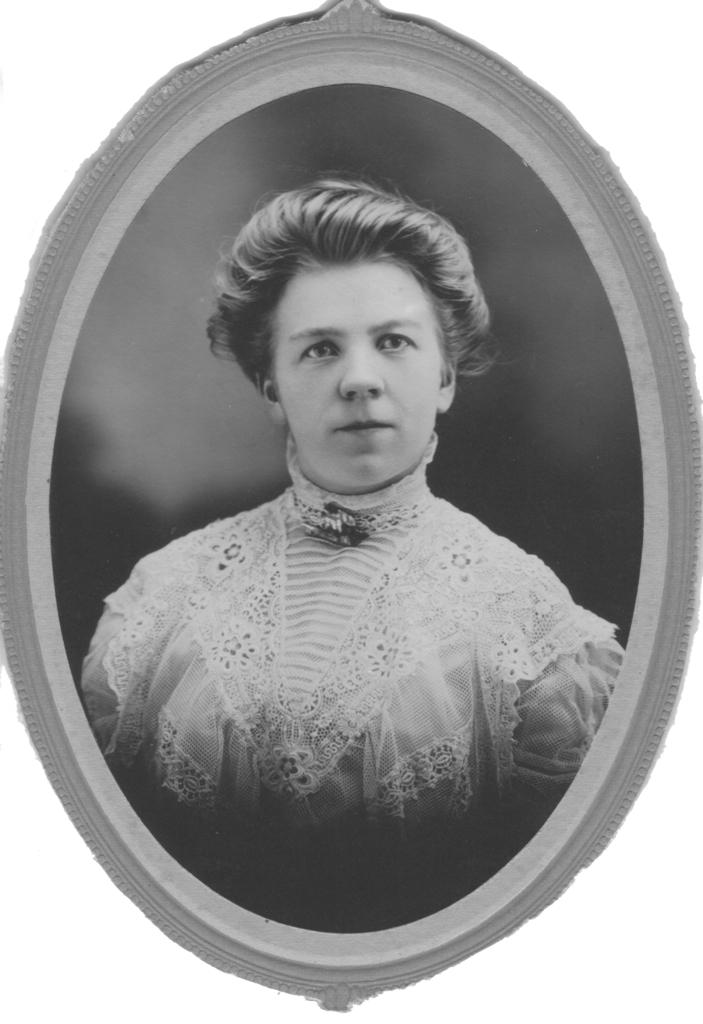What is the color scheme of the image? The image is black and white. Is the image presented in a specific format? Yes, the image is framed. Can you describe the main subject of the image? There is a person in the image. What is the person wearing? The person is wearing a dress. How many ants can be seen crawling on the person's dress in the image? There are no ants present in the image. What type of potato is featured in the image? There is no potato present in the image. 